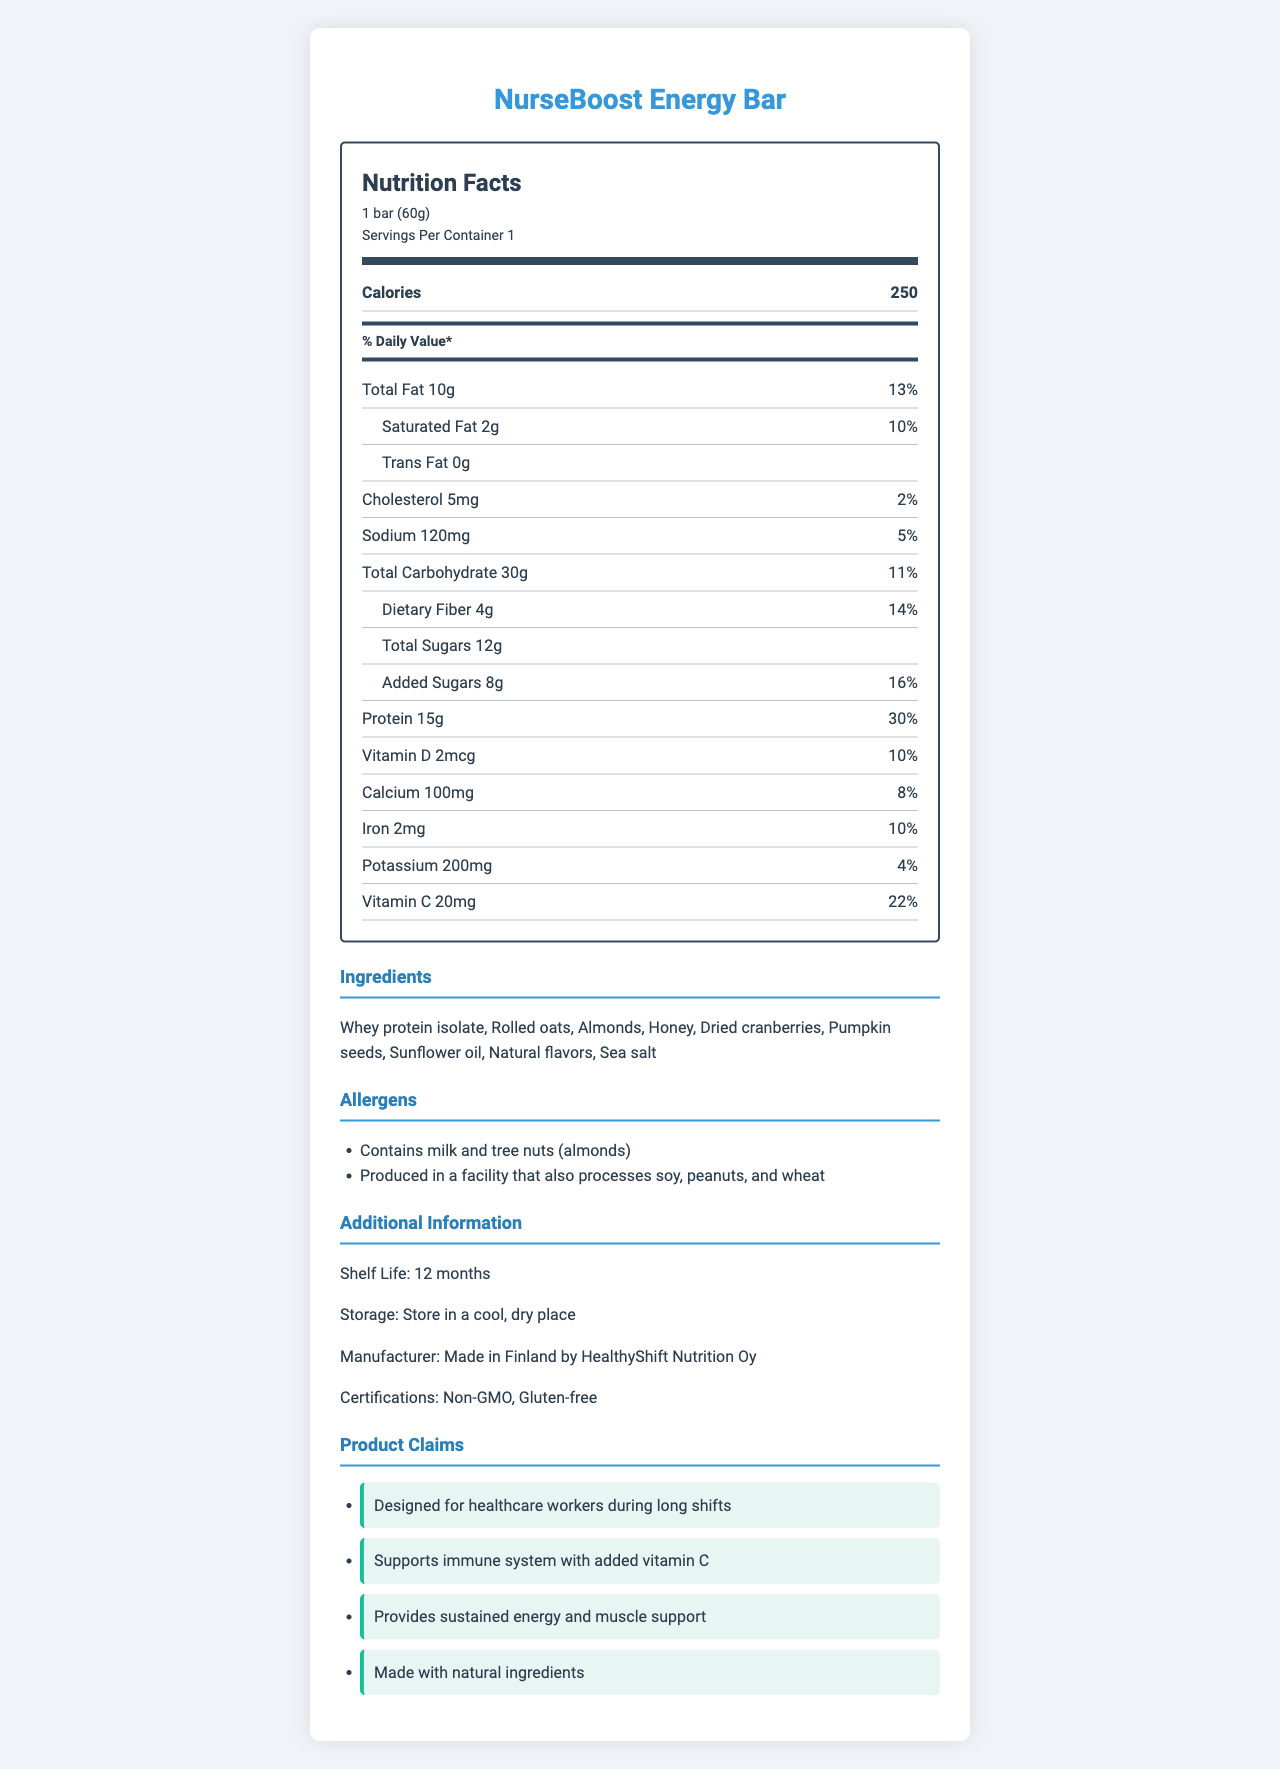what is the serving size for the NurseBoost Energy Bar? The document states the serving size as "1 bar (60g)" near the top.
Answer: 1 bar (60g) how many calories are there per serving? The calories per serving are listed as 250 in the Nutrition Facts section.
Answer: 250 what is the amount of protein in the NurseBoost Energy Bar? The Nutrition Facts states that there are 15g of protein per serving.
Answer: 15g which types of fats are present in the NurseBoost Energy Bar? The document lists total fat, saturated fat, and trans fat.
Answer: Total fat, Saturated fat, Trans fat what allergens are contained in the NurseBoost Energy Bar? The allergens section lists "Contains milk and tree nuts (almonds)".
Answer: Milk and tree nuts (almonds) which ingredient provides the primary source of protein? Whey protein isolate is listed first in the ingredients, indicating it is the primary source of protein.
Answer: Whey protein isolate the nutrition label indicates that the NurseBoost Energy Bar contains how much dietary fiber? The Nutrition Facts section lists 4g of dietary fiber per serving.
Answer: 4g how much vitamin C is in each serving? The document states that there are 20mg of Vitamin C per serving.
Answer: 20mg what percentage of the daily value of calcium does the energy bar provide? The Nutrition Facts states that the bar provides 8% of the daily value of calcium.
Answer: 8% What is the total carbohydrate content in the NurseBoost Energy Bar? A. 40g B. 30g C. 50g The Nutrition Facts section lists the total carbohydrate amount as 30g.
Answer: B. 30g The NurseBoost Energy Bar's shelf life is: A. 12 months B. 6 months C. 18 months D. 24 months The document's additional information states a shelf life of 12 months.
Answer: A. 12 months is the NurseBoost Energy Bar gluten-free? The additional info lists "Gluten-free" as one of the certifications.
Answer: Yes summarize the main features of the NurseBoost Energy Bar. This summary highlights the energy bar's purpose, nutritional content, certifications, allergen information, and key ingredients.
Answer: The NurseBoost Energy Bar is a protein-rich energy bar designed for healthcare workers during long shifts. It contains 250 calories and 15g of protein per serving and is made with natural ingredients. The bar supports the immune system with added Vitamin C, provides sustained energy, and has a shelf life of 12 months. It's certified as Non-GMO and gluten-free. The bar contains milk and tree nuts (almonds) and is produced in a facility that processes soy, peanuts, and wheat. What is the main source of sweeteners used in the NurseBoost Energy Bar? The document does not specify which ingredient is the main source of sweeteners. While it lists honey and dried cranberries, it does not distinguish a primary source.
Answer: Cannot be determined 